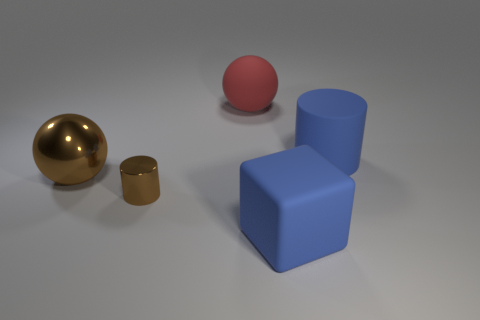Are there more large brown spheres that are in front of the big rubber sphere than big brown cubes?
Your answer should be compact. Yes. What material is the object that is both right of the red rubber thing and behind the blue cube?
Keep it short and to the point. Rubber. Is the color of the matte object on the right side of the large blue cube the same as the big matte object in front of the brown shiny cylinder?
Your answer should be compact. Yes. How many other things are the same size as the metallic cylinder?
Give a very brief answer. 0. There is a large blue object that is in front of the blue rubber thing that is right of the large rubber cube; is there a large object that is to the right of it?
Offer a terse response. Yes. Is the material of the ball that is in front of the matte sphere the same as the large cylinder?
Give a very brief answer. No. There is another large thing that is the same shape as the red thing; what is its color?
Give a very brief answer. Brown. Is the number of big matte blocks behind the large blue matte cylinder the same as the number of big rubber blocks?
Ensure brevity in your answer.  No. Are there any small cylinders in front of the red object?
Your answer should be compact. Yes. What is the size of the cylinder that is on the left side of the blue matte object behind the sphere that is in front of the big matte cylinder?
Make the answer very short. Small. 